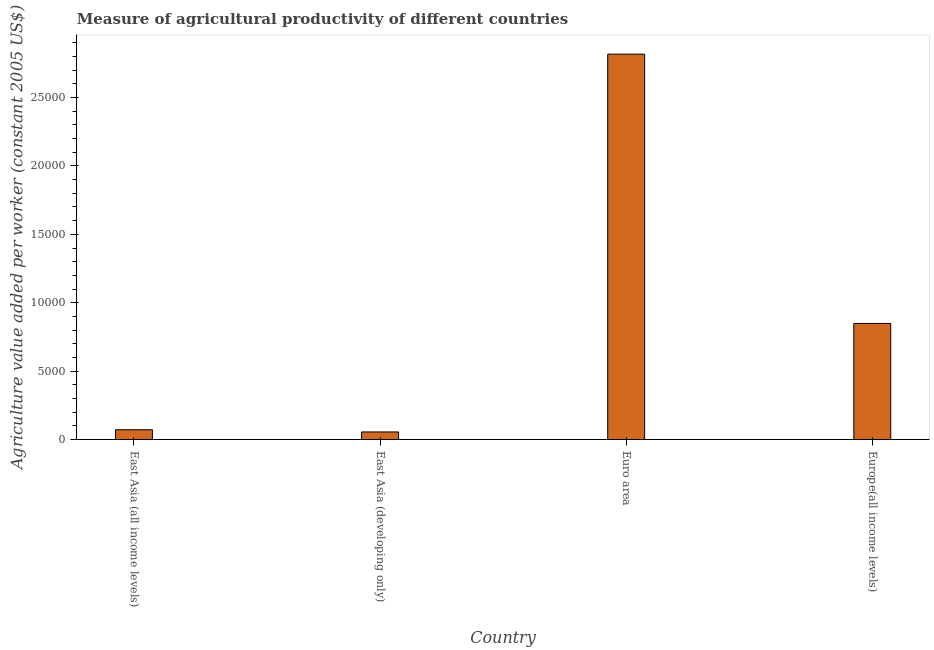Does the graph contain grids?
Give a very brief answer. No. What is the title of the graph?
Your answer should be compact. Measure of agricultural productivity of different countries. What is the label or title of the Y-axis?
Keep it short and to the point. Agriculture value added per worker (constant 2005 US$). What is the agriculture value added per worker in Europe(all income levels)?
Provide a short and direct response. 8484.98. Across all countries, what is the maximum agriculture value added per worker?
Your answer should be compact. 2.82e+04. Across all countries, what is the minimum agriculture value added per worker?
Make the answer very short. 553.75. In which country was the agriculture value added per worker minimum?
Give a very brief answer. East Asia (developing only). What is the sum of the agriculture value added per worker?
Keep it short and to the point. 3.79e+04. What is the difference between the agriculture value added per worker in Euro area and Europe(all income levels)?
Ensure brevity in your answer.  1.97e+04. What is the average agriculture value added per worker per country?
Make the answer very short. 9481.53. What is the median agriculture value added per worker?
Your answer should be compact. 4600.28. In how many countries, is the agriculture value added per worker greater than 19000 US$?
Make the answer very short. 1. What is the ratio of the agriculture value added per worker in East Asia (all income levels) to that in Europe(all income levels)?
Your answer should be compact. 0.08. What is the difference between the highest and the second highest agriculture value added per worker?
Provide a short and direct response. 1.97e+04. What is the difference between the highest and the lowest agriculture value added per worker?
Keep it short and to the point. 2.76e+04. What is the Agriculture value added per worker (constant 2005 US$) of East Asia (all income levels)?
Offer a very short reply. 715.59. What is the Agriculture value added per worker (constant 2005 US$) of East Asia (developing only)?
Ensure brevity in your answer.  553.75. What is the Agriculture value added per worker (constant 2005 US$) in Euro area?
Offer a terse response. 2.82e+04. What is the Agriculture value added per worker (constant 2005 US$) in Europe(all income levels)?
Keep it short and to the point. 8484.98. What is the difference between the Agriculture value added per worker (constant 2005 US$) in East Asia (all income levels) and East Asia (developing only)?
Make the answer very short. 161.83. What is the difference between the Agriculture value added per worker (constant 2005 US$) in East Asia (all income levels) and Euro area?
Your answer should be very brief. -2.75e+04. What is the difference between the Agriculture value added per worker (constant 2005 US$) in East Asia (all income levels) and Europe(all income levels)?
Provide a short and direct response. -7769.39. What is the difference between the Agriculture value added per worker (constant 2005 US$) in East Asia (developing only) and Euro area?
Give a very brief answer. -2.76e+04. What is the difference between the Agriculture value added per worker (constant 2005 US$) in East Asia (developing only) and Europe(all income levels)?
Ensure brevity in your answer.  -7931.23. What is the difference between the Agriculture value added per worker (constant 2005 US$) in Euro area and Europe(all income levels)?
Offer a terse response. 1.97e+04. What is the ratio of the Agriculture value added per worker (constant 2005 US$) in East Asia (all income levels) to that in East Asia (developing only)?
Ensure brevity in your answer.  1.29. What is the ratio of the Agriculture value added per worker (constant 2005 US$) in East Asia (all income levels) to that in Euro area?
Keep it short and to the point. 0.03. What is the ratio of the Agriculture value added per worker (constant 2005 US$) in East Asia (all income levels) to that in Europe(all income levels)?
Offer a terse response. 0.08. What is the ratio of the Agriculture value added per worker (constant 2005 US$) in East Asia (developing only) to that in Euro area?
Keep it short and to the point. 0.02. What is the ratio of the Agriculture value added per worker (constant 2005 US$) in East Asia (developing only) to that in Europe(all income levels)?
Make the answer very short. 0.07. What is the ratio of the Agriculture value added per worker (constant 2005 US$) in Euro area to that in Europe(all income levels)?
Your answer should be compact. 3.32. 